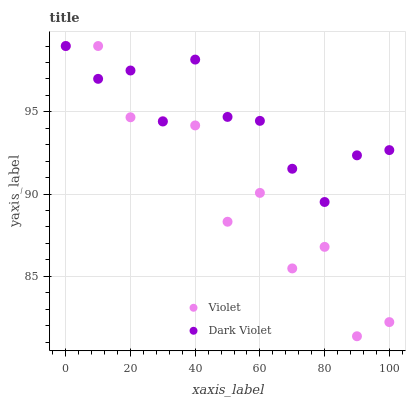Does Violet have the minimum area under the curve?
Answer yes or no. Yes. Does Dark Violet have the maximum area under the curve?
Answer yes or no. Yes. Does Violet have the maximum area under the curve?
Answer yes or no. No. Is Dark Violet the smoothest?
Answer yes or no. Yes. Is Violet the roughest?
Answer yes or no. Yes. Is Violet the smoothest?
Answer yes or no. No. Does Violet have the lowest value?
Answer yes or no. Yes. Does Violet have the highest value?
Answer yes or no. Yes. Does Violet intersect Dark Violet?
Answer yes or no. Yes. Is Violet less than Dark Violet?
Answer yes or no. No. Is Violet greater than Dark Violet?
Answer yes or no. No. 